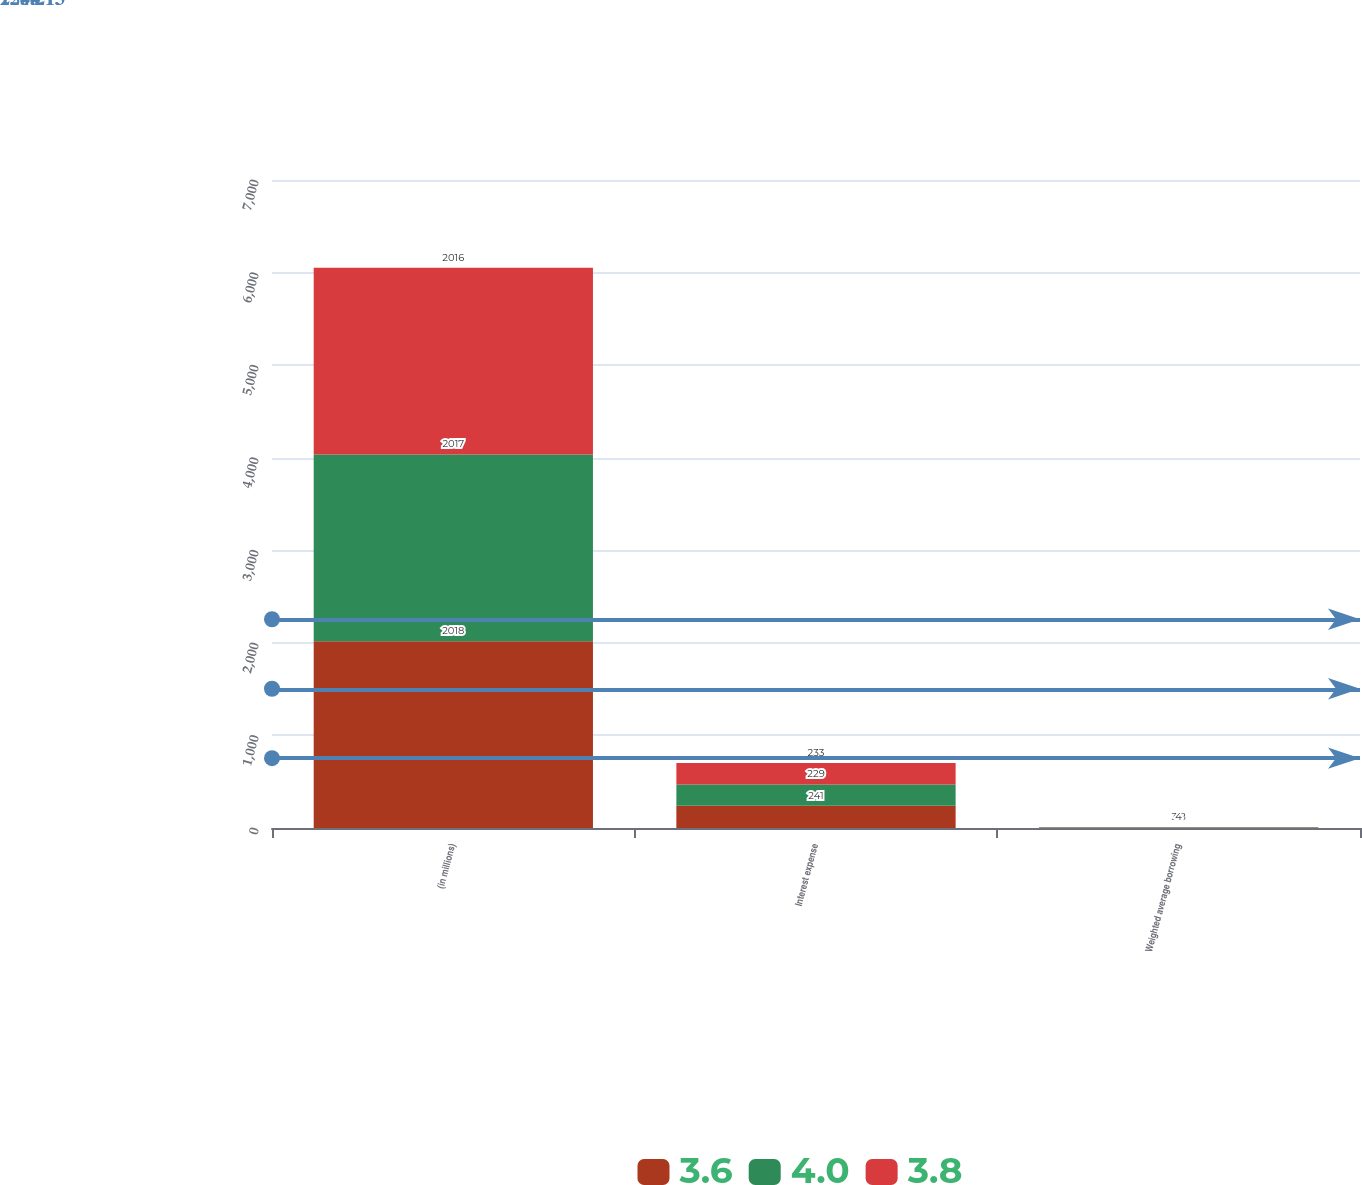Convert chart. <chart><loc_0><loc_0><loc_500><loc_500><stacked_bar_chart><ecel><fcel>(in millions)<fcel>Interest expense<fcel>Weighted average borrowing<nl><fcel>3.6<fcel>2018<fcel>241<fcel>3.6<nl><fcel>4<fcel>2017<fcel>229<fcel>3.8<nl><fcel>3.8<fcel>2016<fcel>233<fcel>4<nl></chart> 